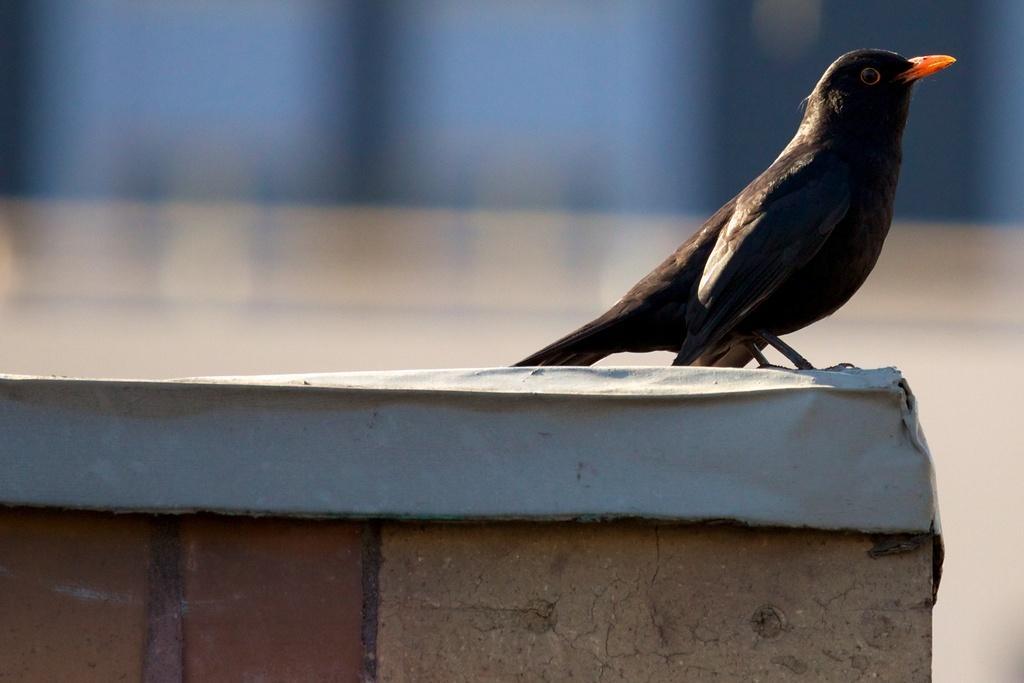In one or two sentences, can you explain what this image depicts? In this image we can see a bird on the wall and background is blurred. 